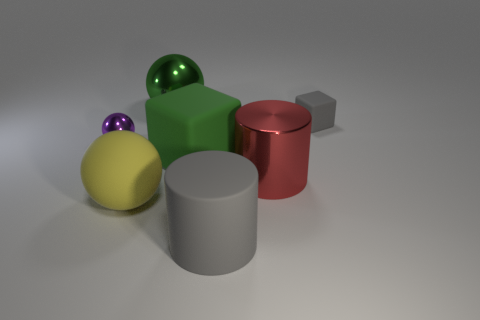There is a gray matte cube; is it the same size as the thing in front of the large matte sphere?
Your response must be concise. No. There is another object that is the same shape as the red thing; what material is it?
Keep it short and to the point. Rubber. What size is the metallic thing left of the large shiny object behind the small gray cube on the right side of the small purple metallic sphere?
Offer a terse response. Small. Do the green metallic ball and the matte cylinder have the same size?
Your response must be concise. Yes. What material is the block that is in front of the metal sphere left of the big matte ball?
Give a very brief answer. Rubber. Is the shape of the gray object in front of the yellow rubber object the same as the small thing that is to the left of the big matte ball?
Offer a very short reply. No. Are there the same number of matte balls behind the big rubber cylinder and cylinders?
Your response must be concise. No. Is there a green rubber object that is left of the small thing left of the big metal sphere?
Provide a succinct answer. No. Is there any other thing that is the same color as the rubber cylinder?
Keep it short and to the point. Yes. Are the big ball that is behind the tiny shiny object and the tiny gray block made of the same material?
Give a very brief answer. No. 